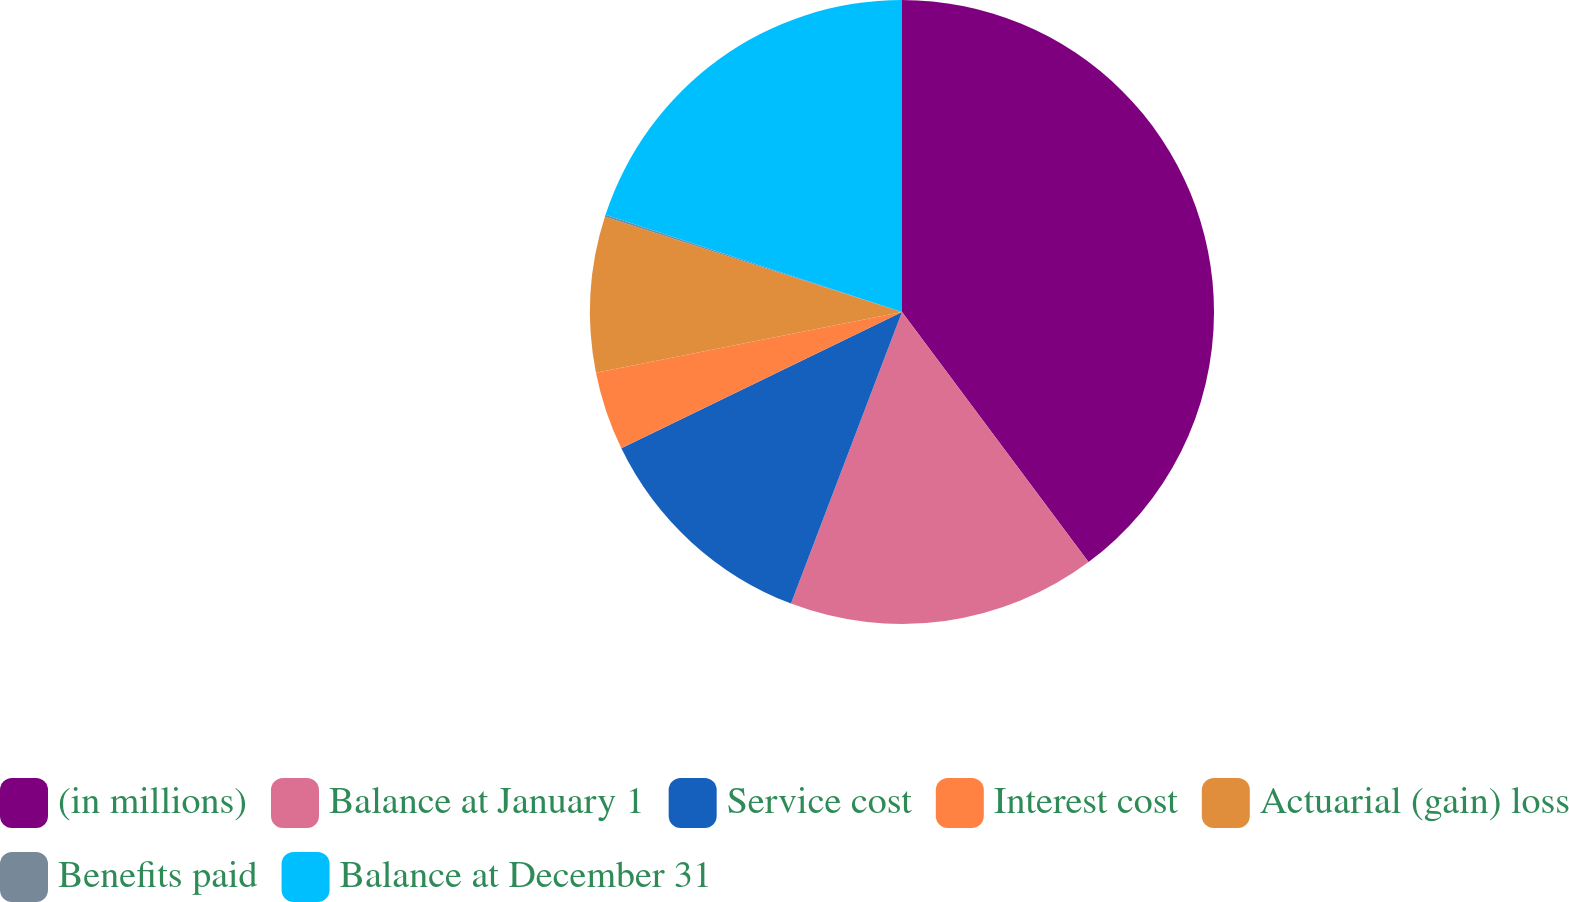Convert chart to OTSL. <chart><loc_0><loc_0><loc_500><loc_500><pie_chart><fcel>(in millions)<fcel>Balance at January 1<fcel>Service cost<fcel>Interest cost<fcel>Actuarial (gain) loss<fcel>Benefits paid<fcel>Balance at December 31<nl><fcel>39.81%<fcel>15.99%<fcel>12.02%<fcel>4.08%<fcel>8.05%<fcel>0.11%<fcel>19.96%<nl></chart> 